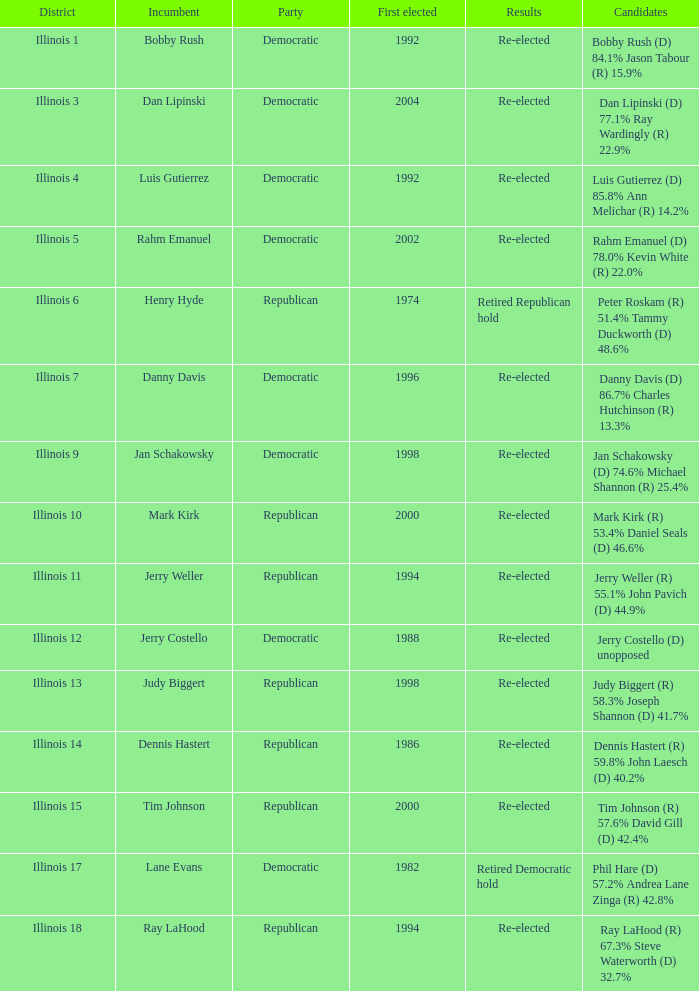What is the region in which the first elected occurred in 1986? Illinois 14. 